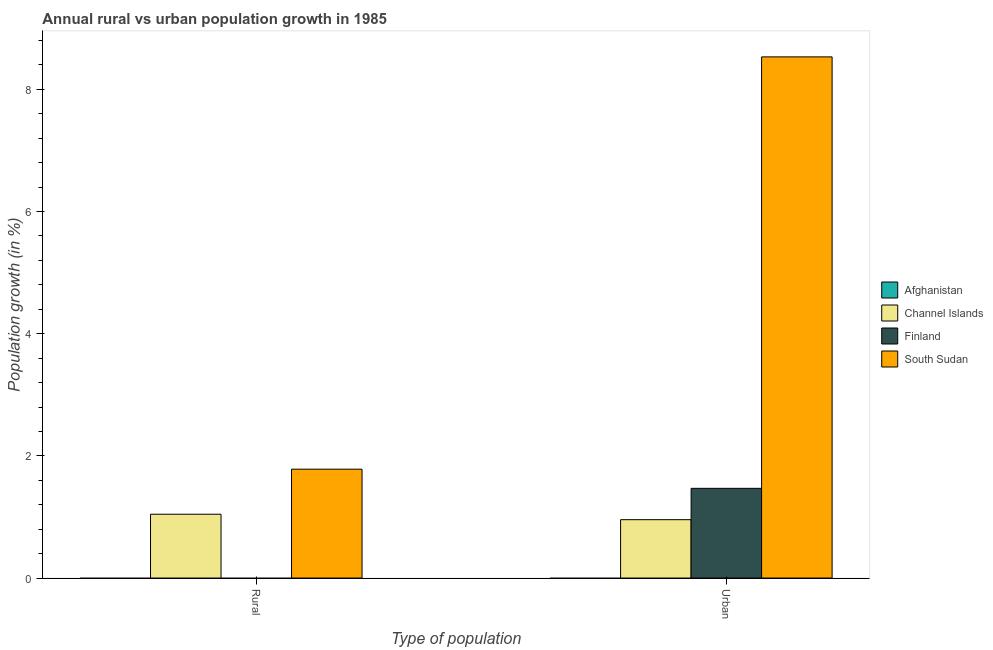How many different coloured bars are there?
Your answer should be compact. 3. Are the number of bars on each tick of the X-axis equal?
Offer a very short reply. No. How many bars are there on the 1st tick from the left?
Offer a terse response. 2. How many bars are there on the 2nd tick from the right?
Give a very brief answer. 2. What is the label of the 2nd group of bars from the left?
Keep it short and to the point. Urban . What is the rural population growth in Afghanistan?
Offer a terse response. 0. Across all countries, what is the maximum urban population growth?
Keep it short and to the point. 8.53. Across all countries, what is the minimum urban population growth?
Make the answer very short. 0. In which country was the urban population growth maximum?
Make the answer very short. South Sudan. What is the total rural population growth in the graph?
Ensure brevity in your answer.  2.83. What is the difference between the urban population growth in Channel Islands and that in Finland?
Give a very brief answer. -0.51. What is the difference between the rural population growth in South Sudan and the urban population growth in Afghanistan?
Your response must be concise. 1.78. What is the average rural population growth per country?
Provide a short and direct response. 0.71. What is the difference between the urban population growth and rural population growth in Channel Islands?
Provide a short and direct response. -0.09. What is the ratio of the urban population growth in Channel Islands to that in Finland?
Offer a very short reply. 0.65. Is the urban population growth in Finland less than that in Channel Islands?
Make the answer very short. No. In how many countries, is the rural population growth greater than the average rural population growth taken over all countries?
Give a very brief answer. 2. Are all the bars in the graph horizontal?
Your answer should be compact. No. How many countries are there in the graph?
Your answer should be compact. 4. How are the legend labels stacked?
Keep it short and to the point. Vertical. What is the title of the graph?
Ensure brevity in your answer.  Annual rural vs urban population growth in 1985. Does "Finland" appear as one of the legend labels in the graph?
Your answer should be very brief. Yes. What is the label or title of the X-axis?
Ensure brevity in your answer.  Type of population. What is the label or title of the Y-axis?
Your response must be concise. Population growth (in %). What is the Population growth (in %) of Channel Islands in Rural?
Your answer should be compact. 1.04. What is the Population growth (in %) of Finland in Rural?
Make the answer very short. 0. What is the Population growth (in %) in South Sudan in Rural?
Ensure brevity in your answer.  1.78. What is the Population growth (in %) in Afghanistan in Urban ?
Offer a terse response. 0. What is the Population growth (in %) in Channel Islands in Urban ?
Provide a succinct answer. 0.96. What is the Population growth (in %) in Finland in Urban ?
Your response must be concise. 1.47. What is the Population growth (in %) of South Sudan in Urban ?
Make the answer very short. 8.53. Across all Type of population, what is the maximum Population growth (in %) of Channel Islands?
Offer a very short reply. 1.04. Across all Type of population, what is the maximum Population growth (in %) of Finland?
Keep it short and to the point. 1.47. Across all Type of population, what is the maximum Population growth (in %) in South Sudan?
Offer a terse response. 8.53. Across all Type of population, what is the minimum Population growth (in %) in Channel Islands?
Give a very brief answer. 0.96. Across all Type of population, what is the minimum Population growth (in %) of South Sudan?
Provide a succinct answer. 1.78. What is the total Population growth (in %) in Channel Islands in the graph?
Your answer should be compact. 2. What is the total Population growth (in %) in Finland in the graph?
Provide a short and direct response. 1.47. What is the total Population growth (in %) in South Sudan in the graph?
Ensure brevity in your answer.  10.31. What is the difference between the Population growth (in %) of Channel Islands in Rural and that in Urban ?
Provide a short and direct response. 0.09. What is the difference between the Population growth (in %) in South Sudan in Rural and that in Urban ?
Give a very brief answer. -6.75. What is the difference between the Population growth (in %) of Channel Islands in Rural and the Population growth (in %) of Finland in Urban?
Your answer should be compact. -0.42. What is the difference between the Population growth (in %) in Channel Islands in Rural and the Population growth (in %) in South Sudan in Urban?
Your answer should be compact. -7.49. What is the average Population growth (in %) of Afghanistan per Type of population?
Make the answer very short. 0. What is the average Population growth (in %) in Finland per Type of population?
Ensure brevity in your answer.  0.73. What is the average Population growth (in %) of South Sudan per Type of population?
Keep it short and to the point. 5.16. What is the difference between the Population growth (in %) in Channel Islands and Population growth (in %) in South Sudan in Rural?
Provide a succinct answer. -0.74. What is the difference between the Population growth (in %) of Channel Islands and Population growth (in %) of Finland in Urban ?
Your response must be concise. -0.51. What is the difference between the Population growth (in %) of Channel Islands and Population growth (in %) of South Sudan in Urban ?
Offer a very short reply. -7.58. What is the difference between the Population growth (in %) of Finland and Population growth (in %) of South Sudan in Urban ?
Keep it short and to the point. -7.06. What is the ratio of the Population growth (in %) in Channel Islands in Rural to that in Urban ?
Make the answer very short. 1.09. What is the ratio of the Population growth (in %) of South Sudan in Rural to that in Urban ?
Your response must be concise. 0.21. What is the difference between the highest and the second highest Population growth (in %) in Channel Islands?
Your answer should be compact. 0.09. What is the difference between the highest and the second highest Population growth (in %) of South Sudan?
Keep it short and to the point. 6.75. What is the difference between the highest and the lowest Population growth (in %) of Channel Islands?
Provide a succinct answer. 0.09. What is the difference between the highest and the lowest Population growth (in %) of Finland?
Offer a very short reply. 1.47. What is the difference between the highest and the lowest Population growth (in %) of South Sudan?
Your answer should be very brief. 6.75. 